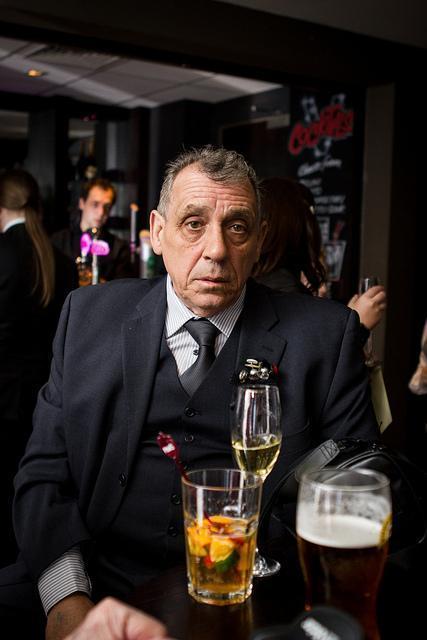How many wine glasses are in the photo?
Give a very brief answer. 1. How many people are there?
Give a very brief answer. 4. How many cups can you see?
Give a very brief answer. 2. How many apples are there?
Give a very brief answer. 0. 